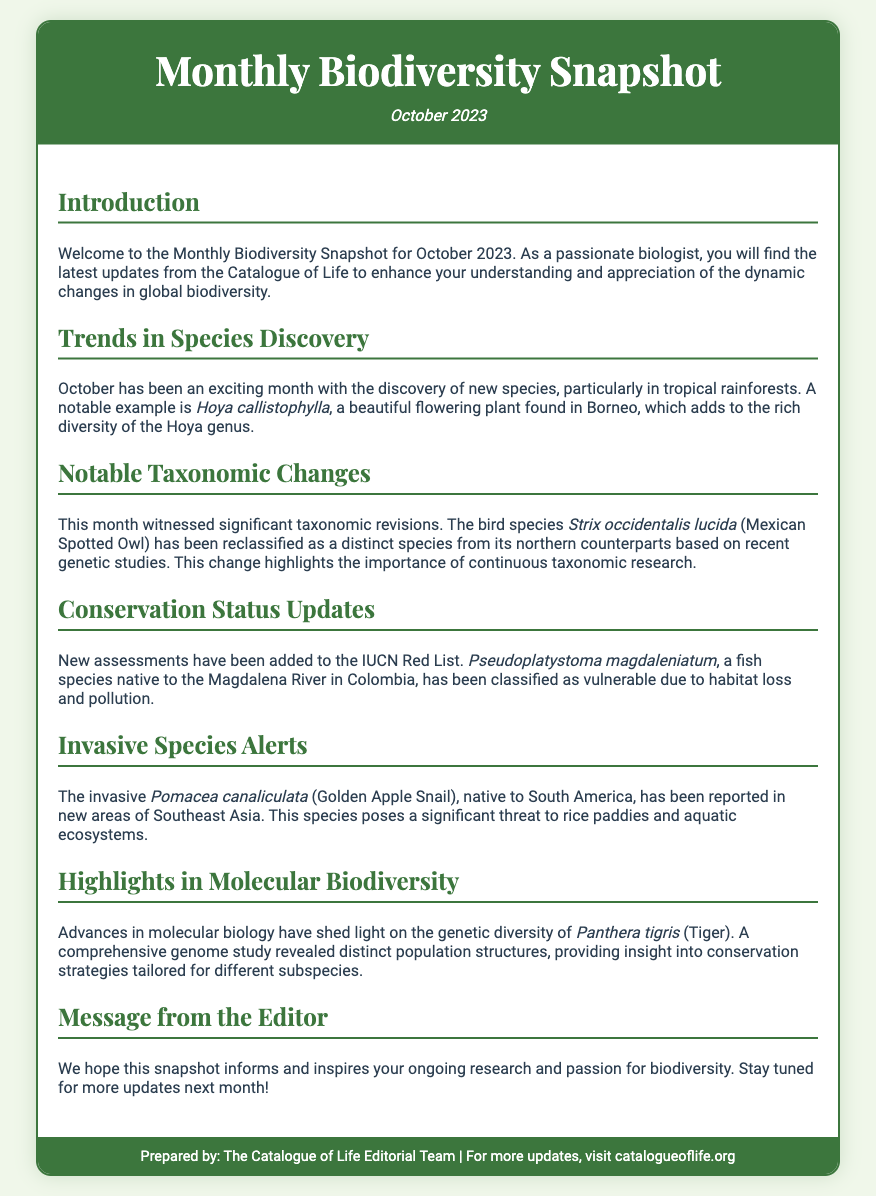What is the date of the Monthly Biodiversity Snapshot? The date of the snapshot is clearly stated in the header of the document.
Answer: October 2023 What is the notable flowering plant discovered in October? The document mentions a specific plant as an example of new species discovered in this month.
Answer: Hoya callistophylla Which species was reclassified as a distinct species based on genetic studies? The revision is highlighted in the section about notable taxonomic changes.
Answer: Strix occidentalis lucida What is the conservation status of Pseudoplatystoma magdaleniatum? The status is specified in the conservation updates section of the document.
Answer: Vulnerable What invasive species has been reported in new areas of Southeast Asia? The document identifies a specific invasive species related to this issue.
Answer: Pomacea canaliculata What major advancement was mentioned regarding Panthera tigris? This highlights a specific area of research mentioned in the snapshot.
Answer: Genome study What does the editor hope for the readers in the closing message? The closing message conveys the intent behind the information shared in the document.
Answer: Inform and inspire What type of ecosystems does Pomacea canaliculata threaten? This question focuses on the potential impact of the invasive species mentioned.
Answer: Rice paddies and aquatic ecosystems 